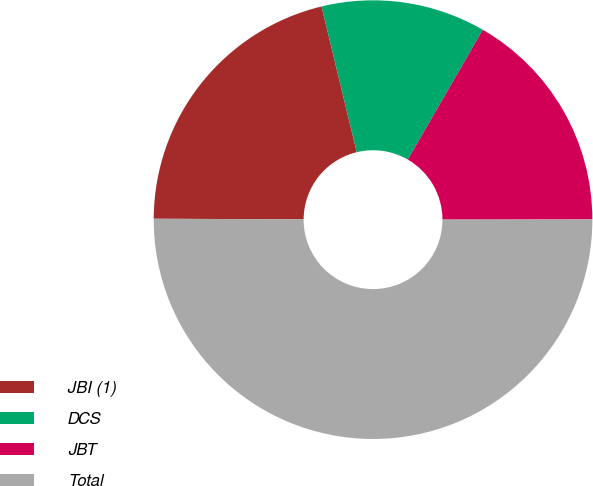Convert chart. <chart><loc_0><loc_0><loc_500><loc_500><pie_chart><fcel>JBI (1)<fcel>DCS<fcel>JBT<fcel>Total<nl><fcel>21.16%<fcel>12.12%<fcel>16.64%<fcel>50.08%<nl></chart> 